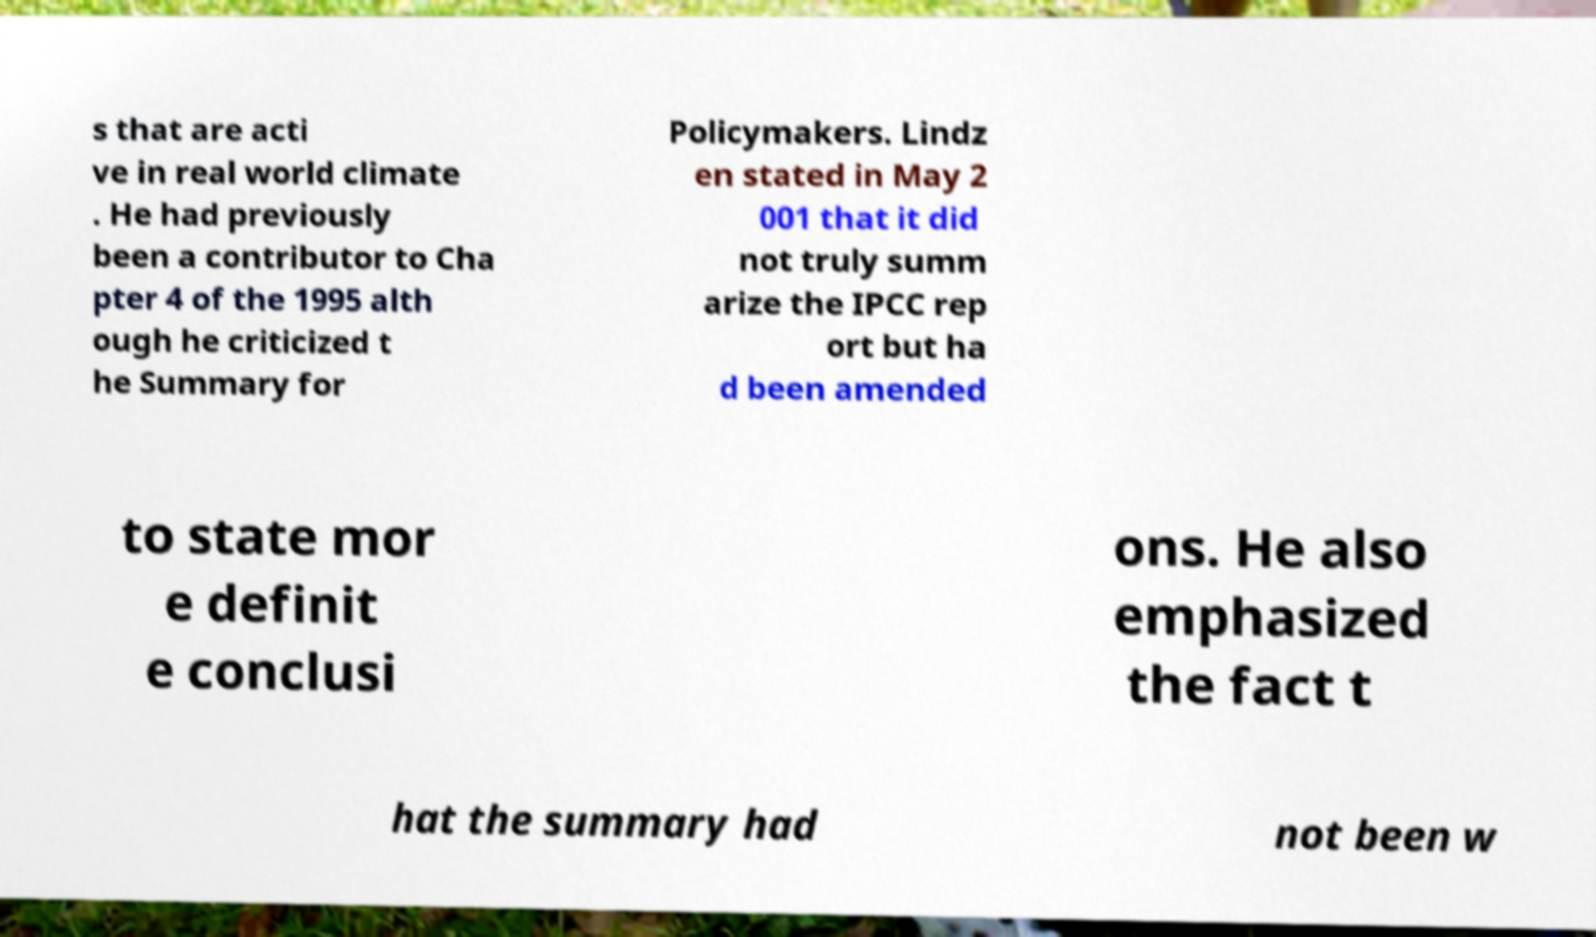Can you accurately transcribe the text from the provided image for me? s that are acti ve in real world climate . He had previously been a contributor to Cha pter 4 of the 1995 alth ough he criticized t he Summary for Policymakers. Lindz en stated in May 2 001 that it did not truly summ arize the IPCC rep ort but ha d been amended to state mor e definit e conclusi ons. He also emphasized the fact t hat the summary had not been w 